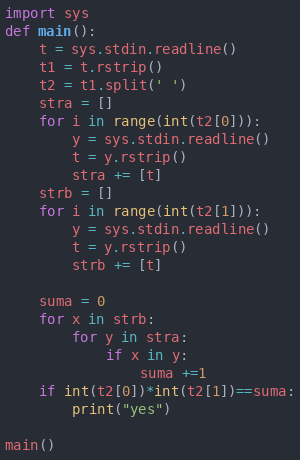Convert code to text. <code><loc_0><loc_0><loc_500><loc_500><_Python_>import sys
def main():
    t = sys.stdin.readline()
    t1 = t.rstrip()
    t2 = t1.split(' ')
    stra = [] 
    for i in range(int(t2[0])):
        y = sys.stdin.readline()
        t = y.rstrip()
        stra += [t]
    strb = [] 
    for i in range(int(t2[1])):
        y = sys.stdin.readline()
        t = y.rstrip()
        strb += [t]

    suma = 0
    for x in strb:
        for y in stra:
            if x in y:
                suma +=1 
    if int(t2[0])*int(t2[1])==suma:
        print("yes")

main()</code> 